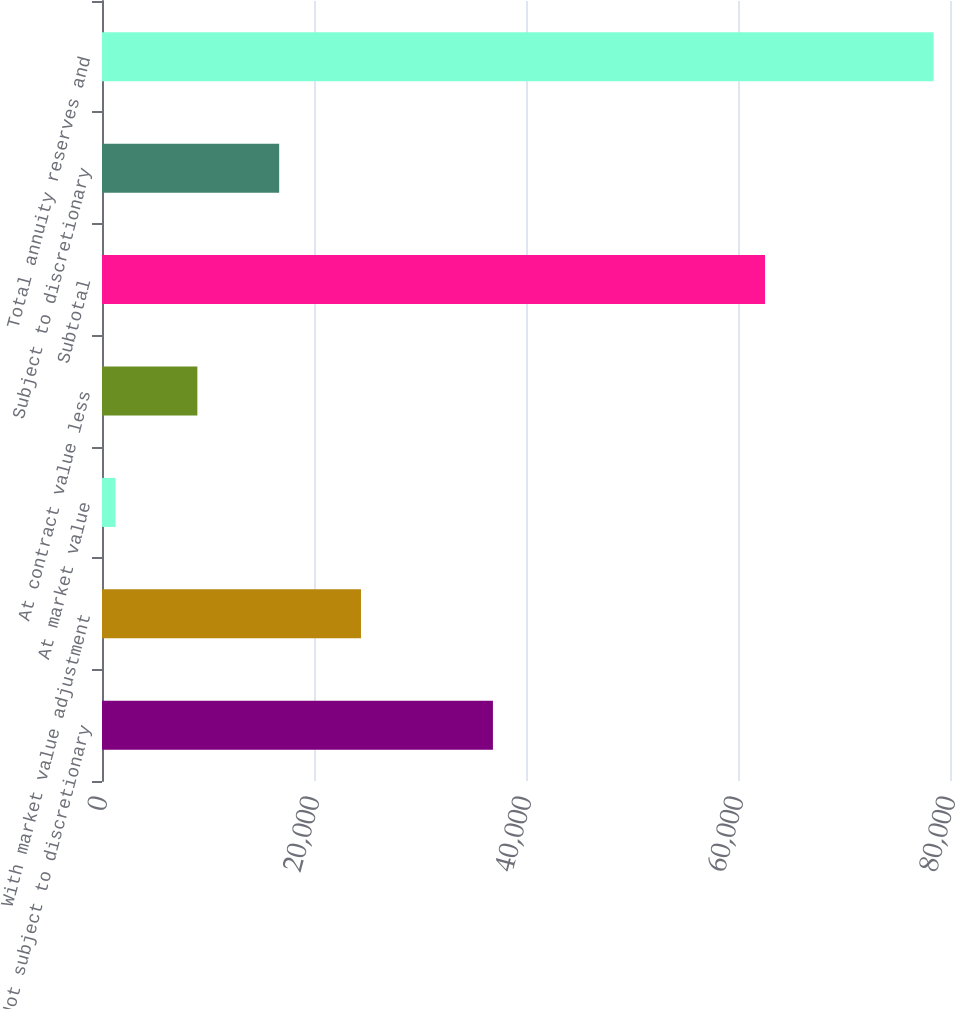Convert chart. <chart><loc_0><loc_0><loc_500><loc_500><bar_chart><fcel>Not subject to discretionary<fcel>With market value adjustment<fcel>At market value<fcel>At contract value less<fcel>Subtotal<fcel>Subject to discretionary<fcel>Total annuity reserves and<nl><fcel>36880<fcel>24431.5<fcel>1279<fcel>8996.5<fcel>62548<fcel>16714<fcel>78454<nl></chart> 